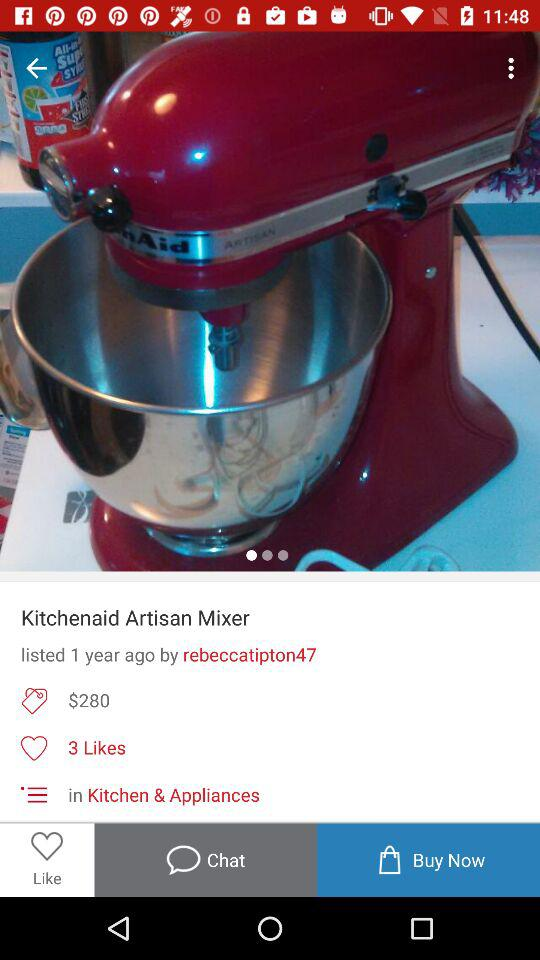How many likes are there on this item?
Answer the question using a single word or phrase. 3 